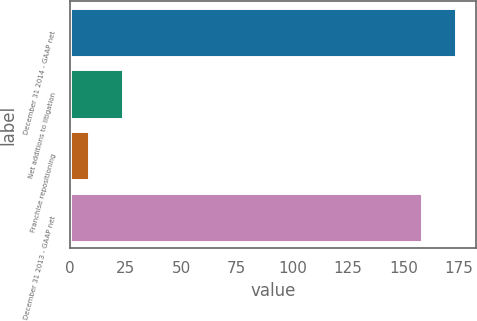<chart> <loc_0><loc_0><loc_500><loc_500><bar_chart><fcel>December 31 2014 - GAAP net<fcel>Net additions to litigation<fcel>Franchise repositioning<fcel>December 31 2013 - GAAP net<nl><fcel>173.7<fcel>24.1<fcel>8.6<fcel>158.2<nl></chart> 